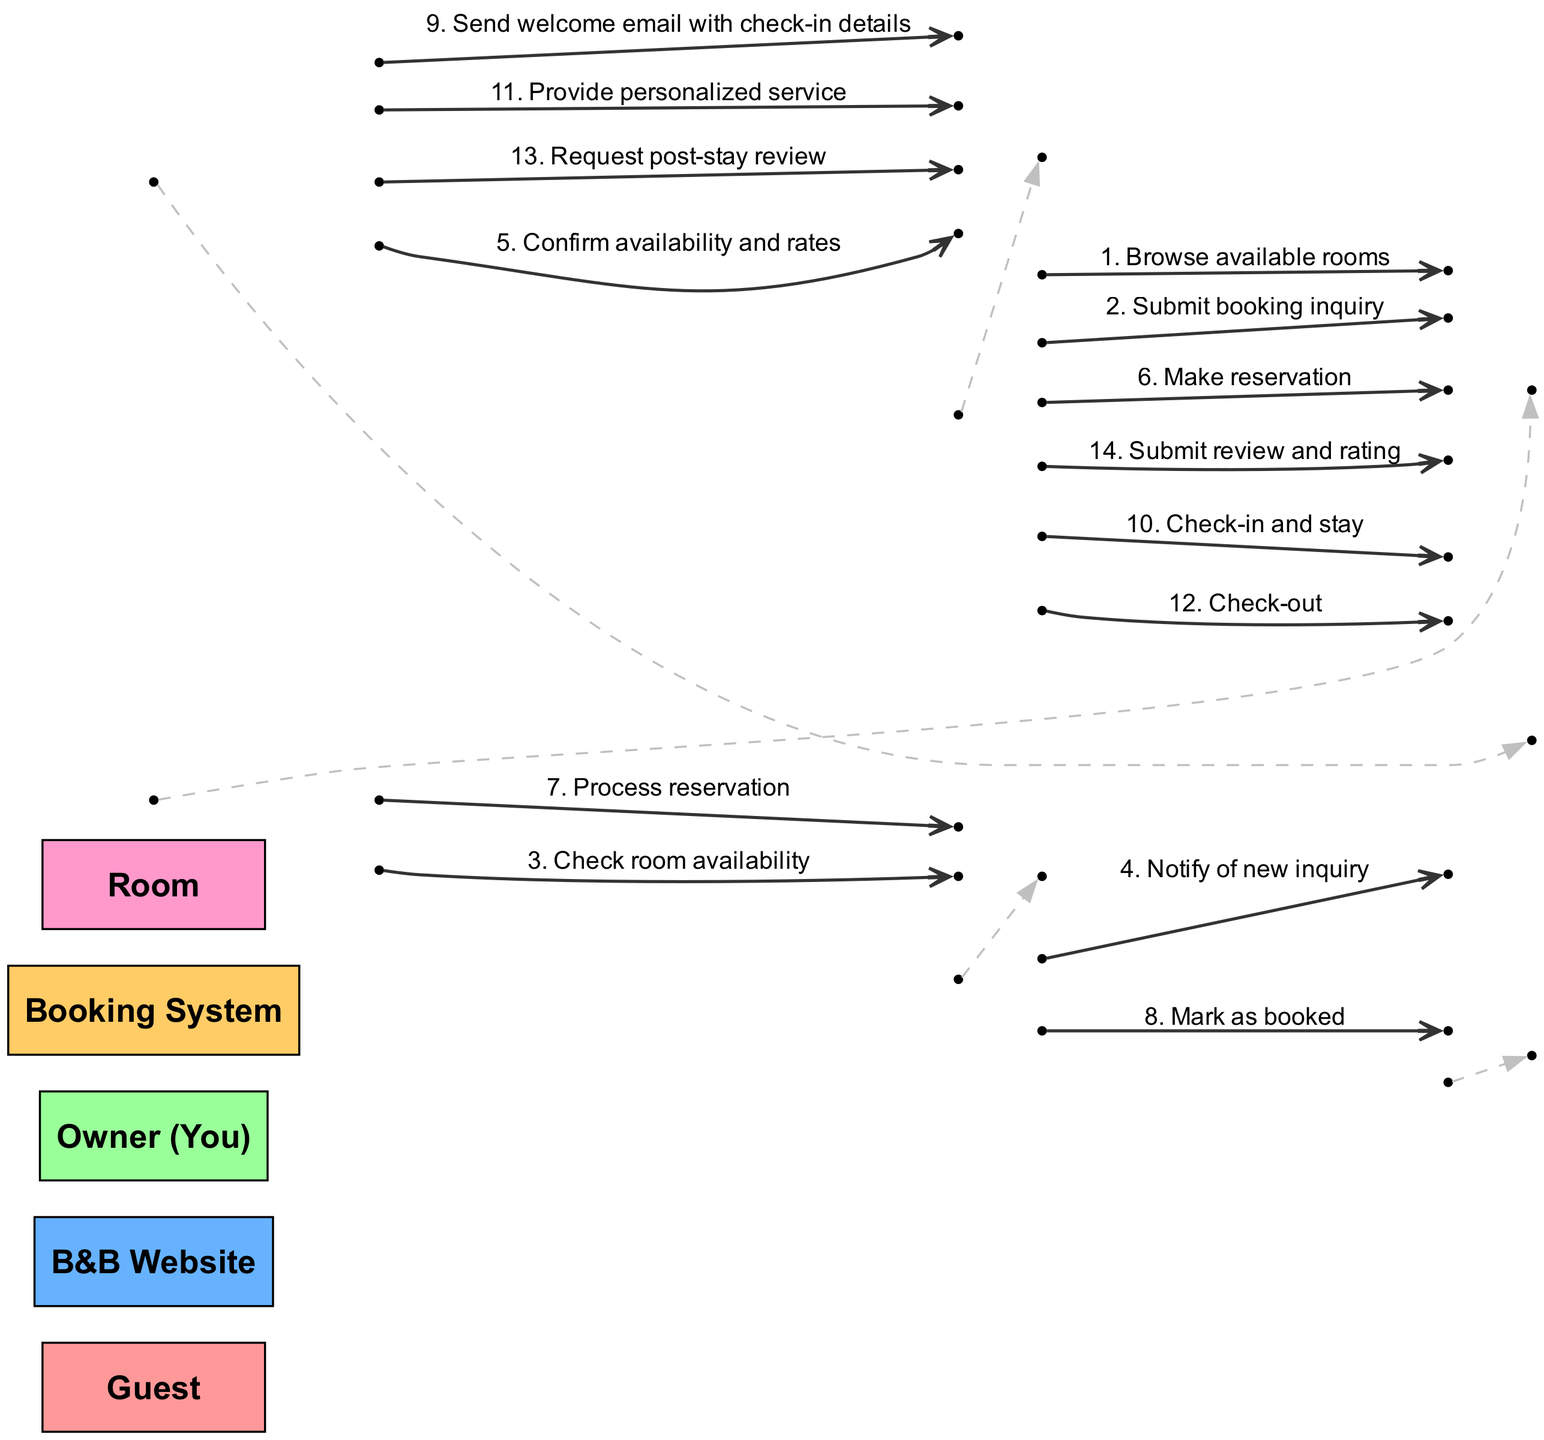What's the first action the Guest takes? The diagram indicates that the first action taken by the Guest is to "Browse available rooms," which is the initial step in the sequence.
Answer: Browse available rooms How many actors are involved in the sequence? By reviewing the list of actors, there are a total of five actors listed: Guest, B&B Website, Owner (You), Booking System, and Room.
Answer: 5 What message does the Owner send after notifying of a new inquiry? Looking at the sequence, the Owner sends a message to the Guest stating "Confirm availability and rates" after being notified of a new inquiry by the Booking System.
Answer: Confirm availability and rates Which actor marks the room as booked? The diagram shows that the Booking System is responsible for the action of marking the room as booked after processing the reservation.
Answer: Booking System What is the final action the Guest takes in the sequence? The final action taken by the Guest, as indicated at the end of the sequence, is "Submit review and rating" after their stay.
Answer: Submit review and rating How many messages does the Owner send throughout the sequence? The Owner sends three messages total: confirming availability and rates, sending a welcome email, and requesting a post-stay review.
Answer: 3 What step immediately follows the Guest's check-in? After the Guest checks in, the next step in the sequence is the Owner providing personalized service to the Guest during their stay.
Answer: Provide personalized service Which actor is responsible for checking room availability? According to the sequence, the B&B Website communicates with the Booking System to check room availability after the Guest submits a booking inquiry.
Answer: B&B Website What happens after the Guest makes a reservation? Once the Guest makes a reservation, the B&B Website processes the reservation through the Booking System, marking the room as booked subsequently.
Answer: Process reservation 